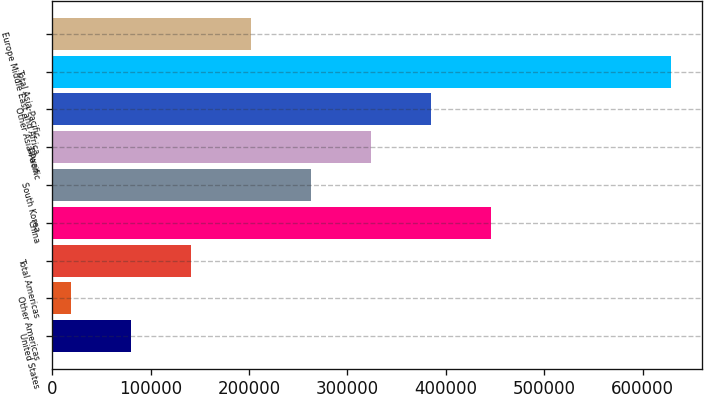Convert chart to OTSL. <chart><loc_0><loc_0><loc_500><loc_500><bar_chart><fcel>United States<fcel>Other Americas<fcel>Total Americas<fcel>China<fcel>South Korea<fcel>Taiwan<fcel>Other Asia-Pacific<fcel>Total Asia-Pacific<fcel>Europe Middle East and Africa<nl><fcel>79938.6<fcel>18925<fcel>140952<fcel>446020<fcel>262979<fcel>323993<fcel>385007<fcel>629061<fcel>201966<nl></chart> 